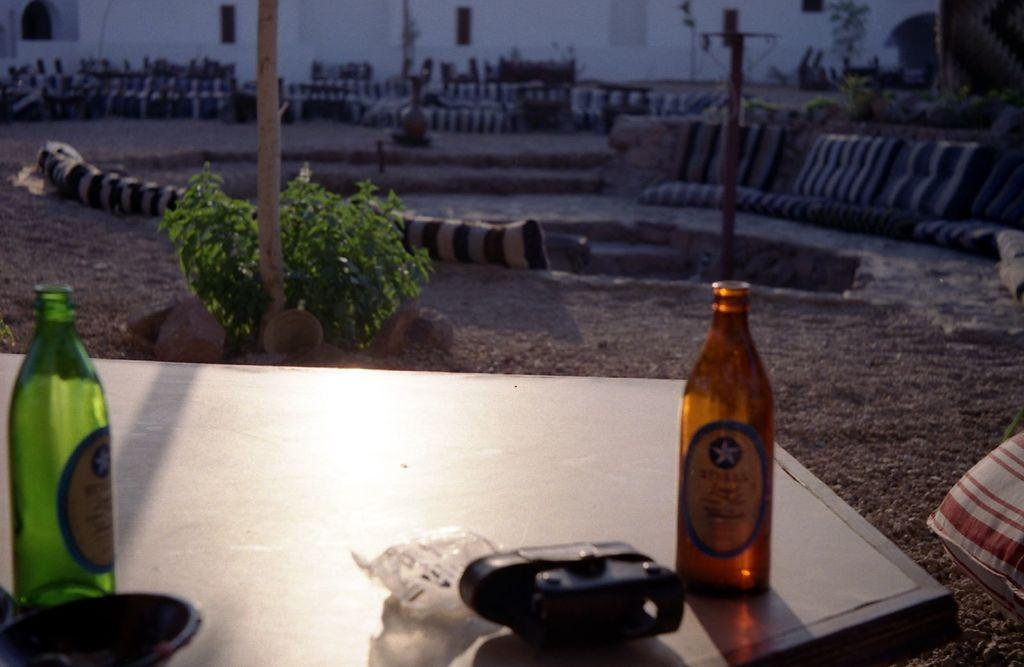What is located at the bottom of the image? There is a table at the bottom of the image. What can be seen on the table? There are bottles and other objects placed on the table. What is visible in the background of the image? There are cushions, plants, poles, and a wall in the background of the image. What type of eggnog is being served in the crate in the image? There is no crate or eggnog present in the image. How many cents are visible on the poles in the background? There are no cents visible on the poles in the background; they are simply poles. 